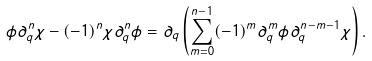<formula> <loc_0><loc_0><loc_500><loc_500>\phi \partial ^ { n } _ { q } \chi - ( - 1 ) ^ { n } \chi \partial ^ { n } _ { q } \phi = \partial _ { q } \left ( \sum ^ { n - 1 } _ { m = 0 } ( - 1 ) ^ { m } \partial ^ { m } _ { q } \phi \partial ^ { n - m - 1 } _ { q } \chi \right ) .</formula> 